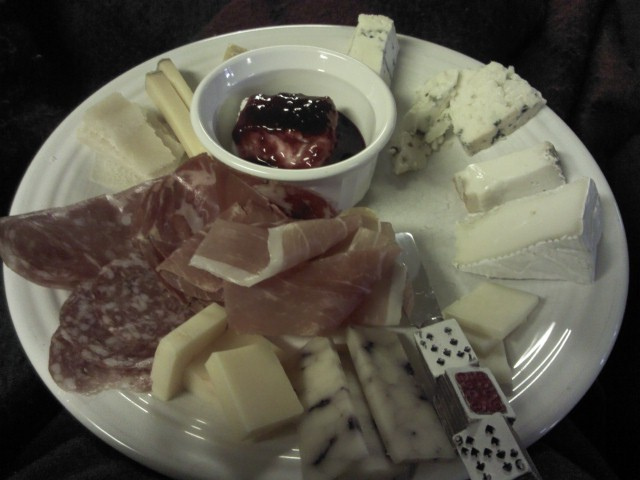Apart from cheese, I see other food items on the plate. Can you name them and suggest a type of wine that pairs well with this assortment? In addition to the variety of cheeses, the plate features slices of cured meats such as salami and prosciutto, as well as some fruit jam. For this charcuterie and cheese platter, a medium-bodied red wine like a Merlot or a Pinot Noir would pair wonderfully, as they can complement both the savory flavors of the meat and the richness of the cheeses, without overpowering them. 